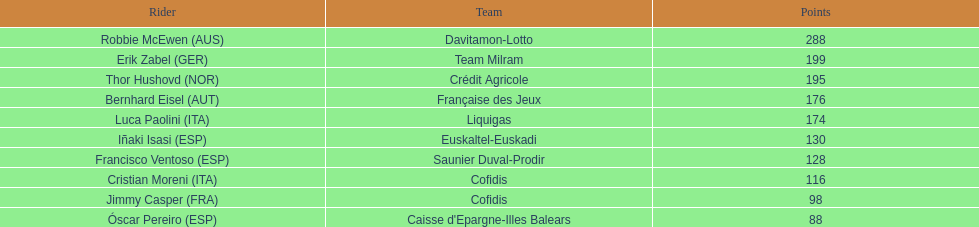How many points did robbie mcewen and cristian moreni score together? 404. 